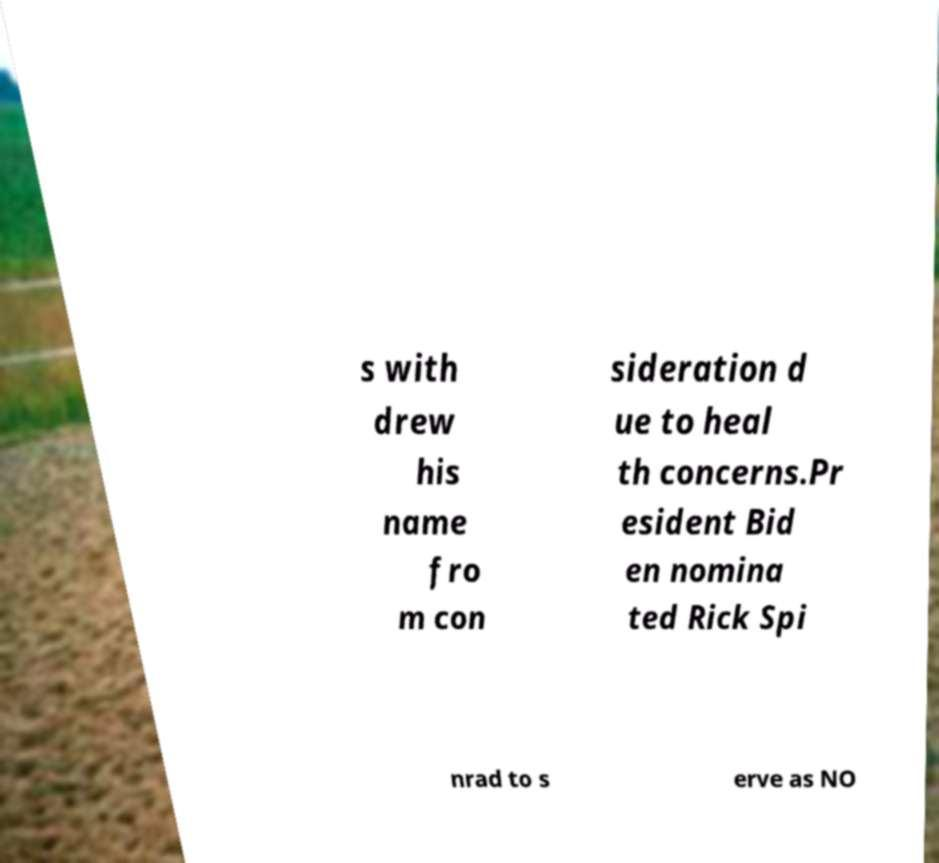Please identify and transcribe the text found in this image. s with drew his name fro m con sideration d ue to heal th concerns.Pr esident Bid en nomina ted Rick Spi nrad to s erve as NO 